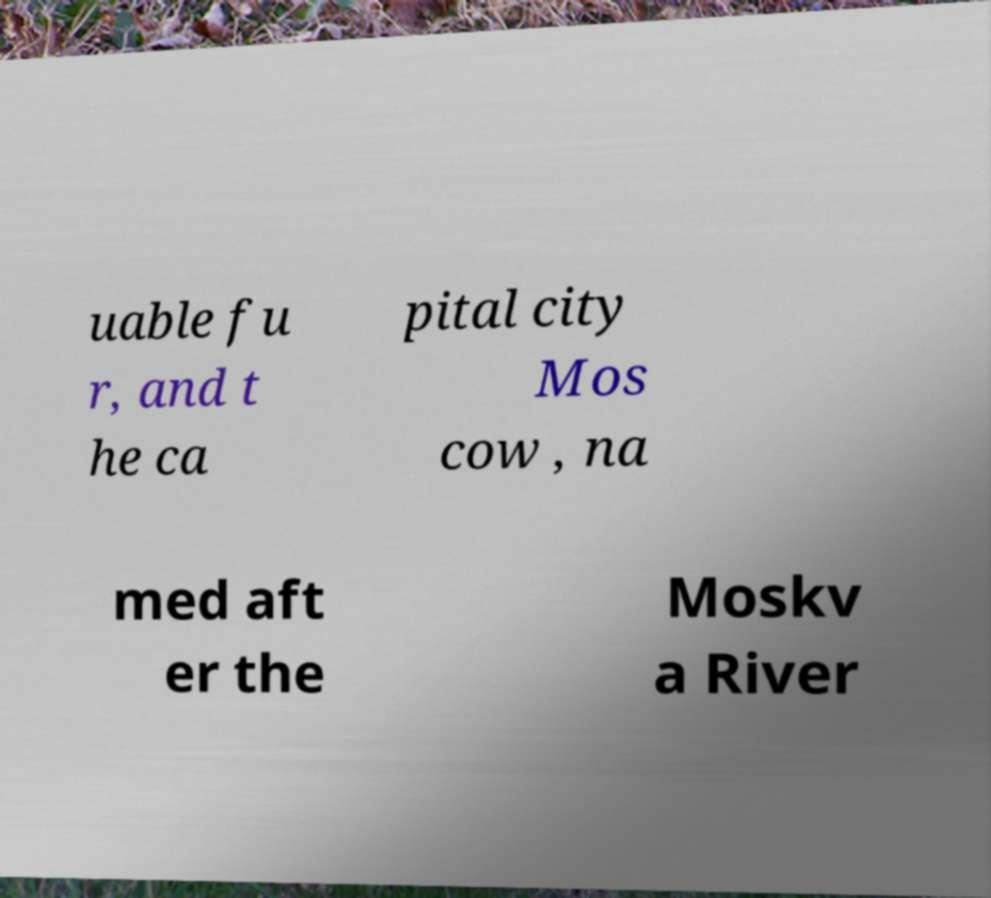Please read and relay the text visible in this image. What does it say? uable fu r, and t he ca pital city Mos cow , na med aft er the Moskv a River 